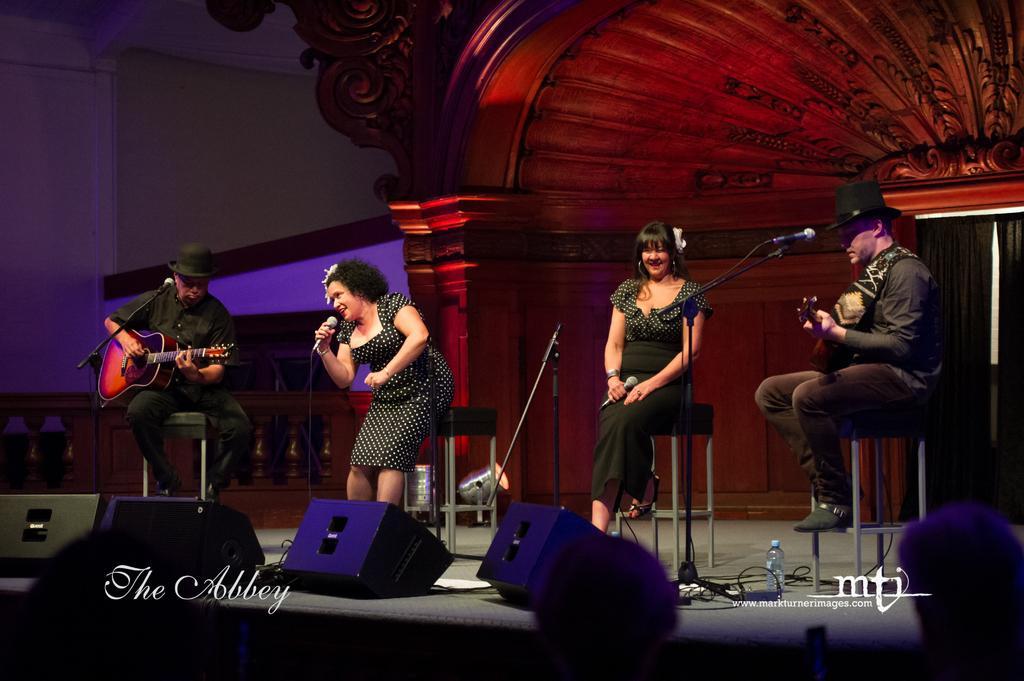Could you give a brief overview of what you see in this image? there are two men playing guitar and two women singing songs in a microphone they are presenting a stage show. 